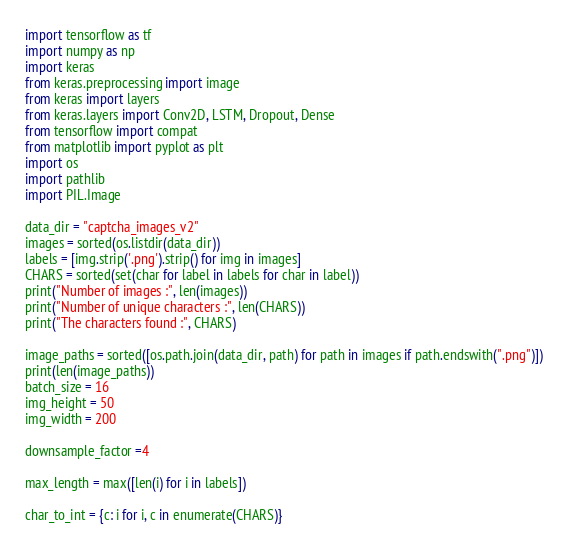Convert code to text. <code><loc_0><loc_0><loc_500><loc_500><_Python_>import tensorflow as tf
import numpy as np
import keras
from keras.preprocessing import image
from keras import layers
from keras.layers import Conv2D, LSTM, Dropout, Dense
from tensorflow import compat
from matplotlib import pyplot as plt
import os
import pathlib
import PIL.Image

data_dir = "captcha_images_v2"
images = sorted(os.listdir(data_dir))
labels = [img.strip('.png').strip() for img in images]
CHARS = sorted(set(char for label in labels for char in label))
print("Number of images :", len(images))
print("Number of unique characters :", len(CHARS))
print("The characters found :", CHARS)

image_paths = sorted([os.path.join(data_dir, path) for path in images if path.endswith(".png")])
print(len(image_paths))
batch_size = 16
img_height = 50
img_width = 200

downsample_factor =4

max_length = max([len(i) for i in labels])

char_to_int = {c: i for i, c in enumerate(CHARS)}</code> 